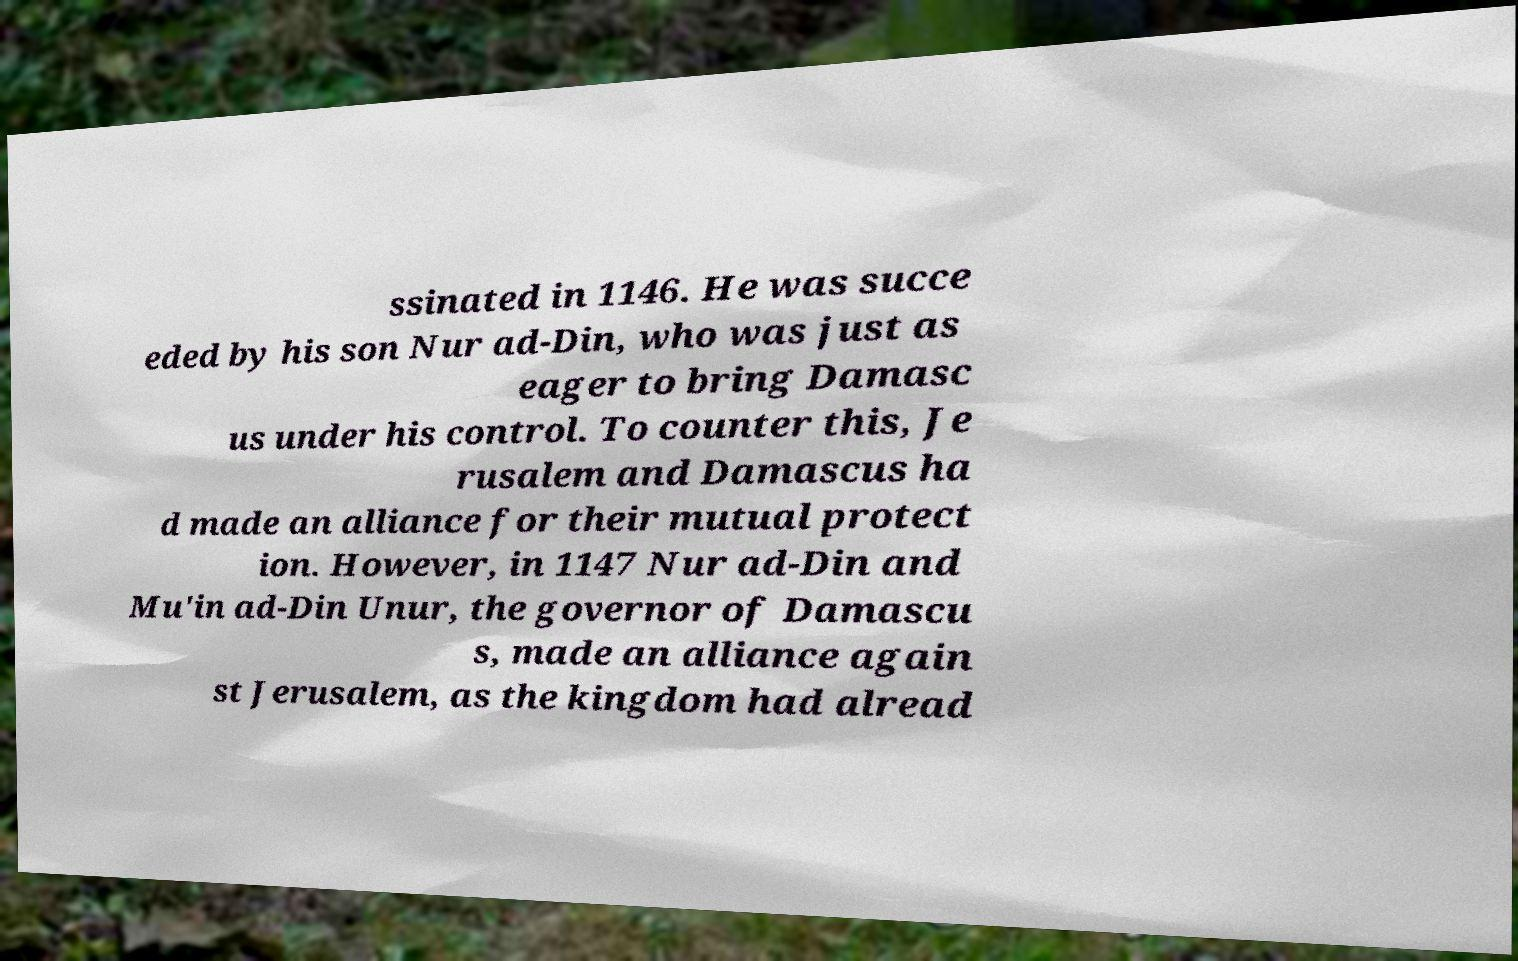For documentation purposes, I need the text within this image transcribed. Could you provide that? ssinated in 1146. He was succe eded by his son Nur ad-Din, who was just as eager to bring Damasc us under his control. To counter this, Je rusalem and Damascus ha d made an alliance for their mutual protect ion. However, in 1147 Nur ad-Din and Mu'in ad-Din Unur, the governor of Damascu s, made an alliance again st Jerusalem, as the kingdom had alread 